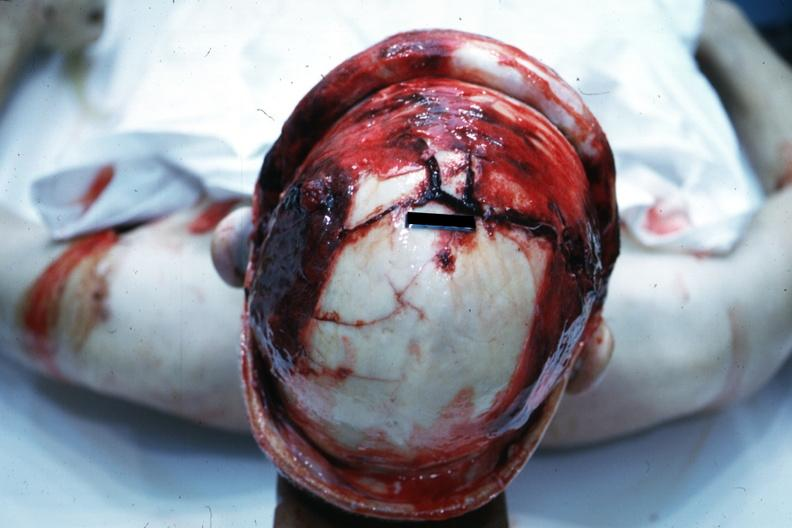s view of head with scalp retracted to show massive fractures?
Answer the question using a single word or phrase. Yes 